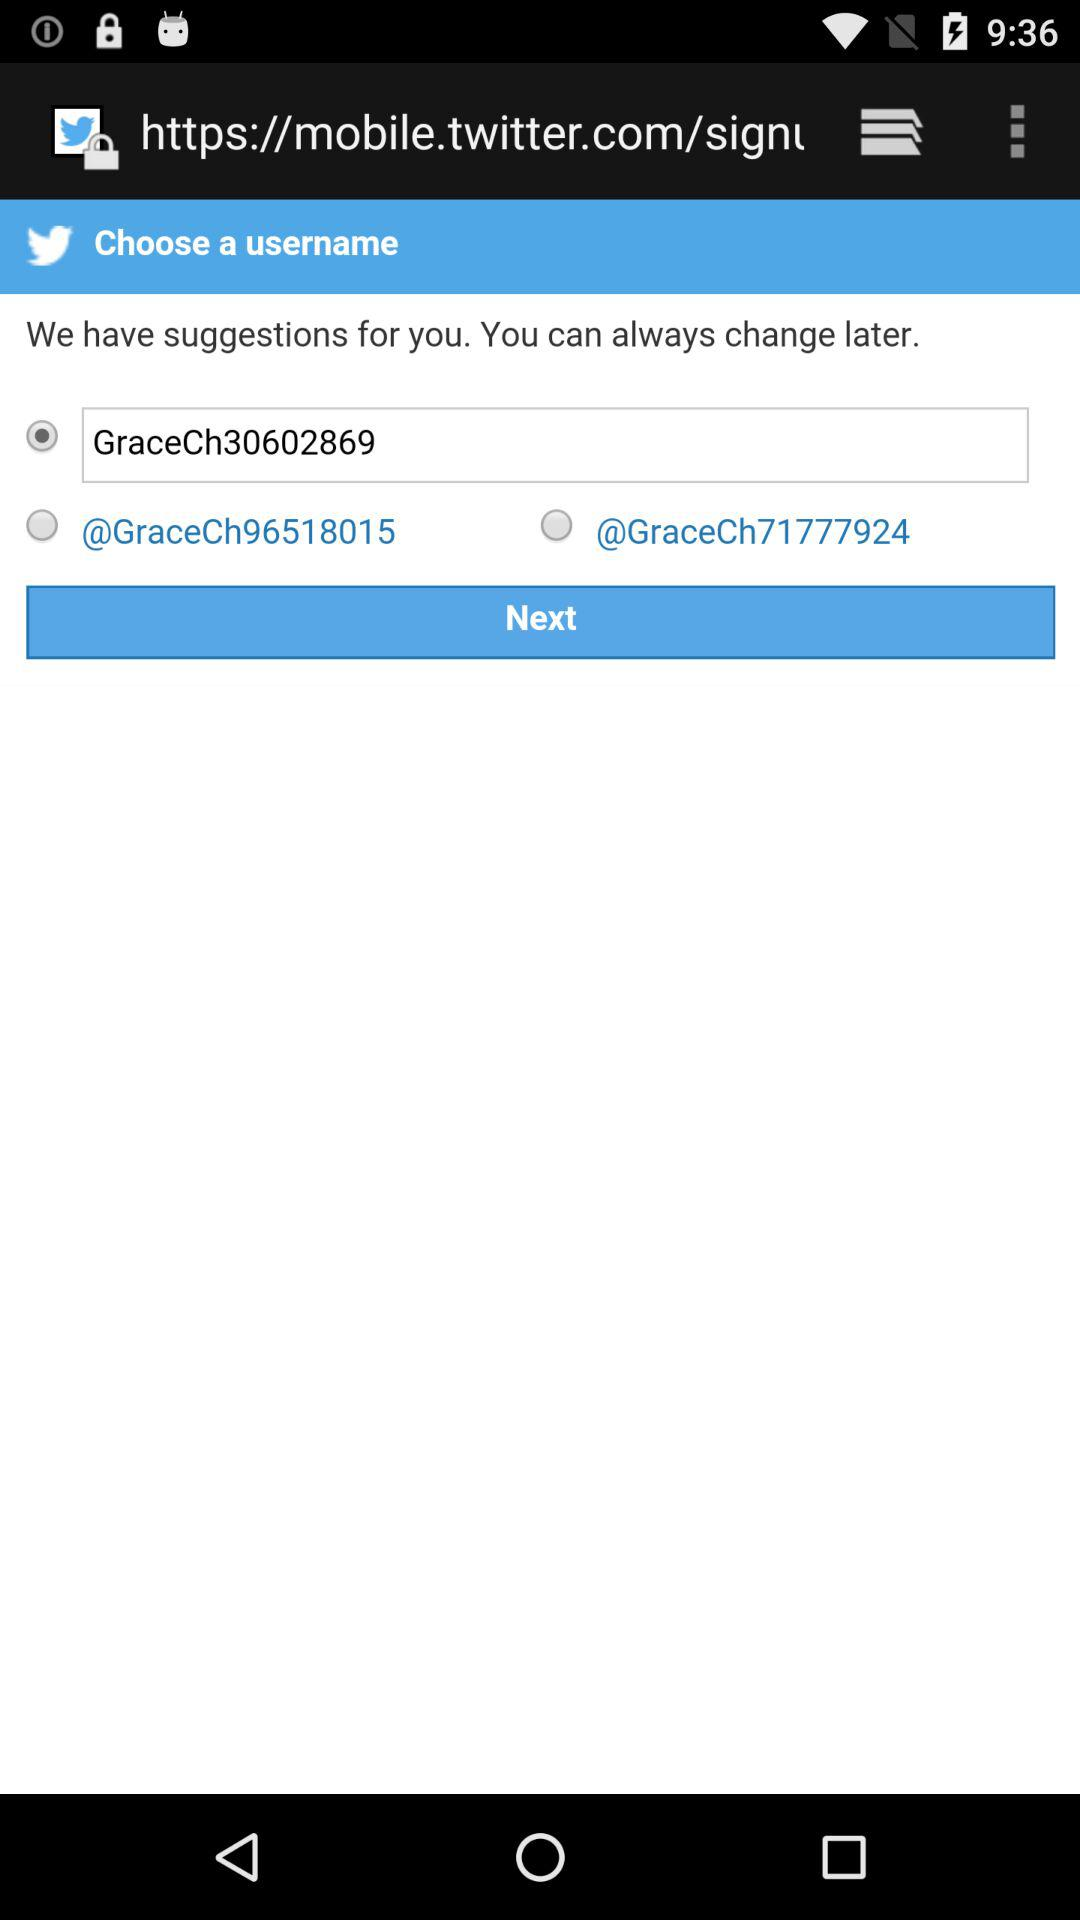Which username is selected? The selected username is "GraceCh30602869". 